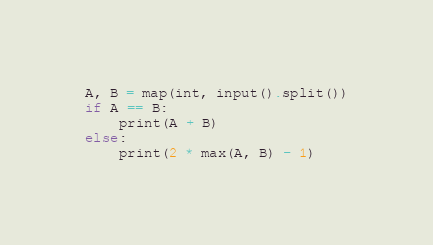Convert code to text. <code><loc_0><loc_0><loc_500><loc_500><_Python_>A, B = map(int, input().split())
if A == B:
    print(A + B)
else:
    print(2 * max(A, B) - 1)
</code> 